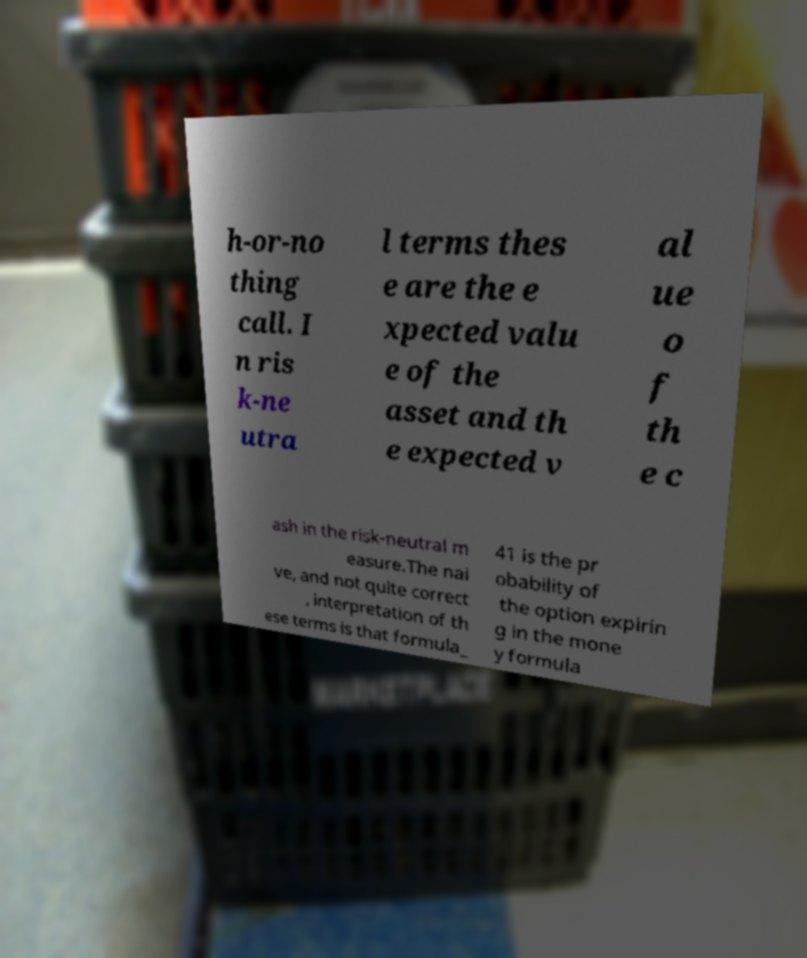I need the written content from this picture converted into text. Can you do that? h-or-no thing call. I n ris k-ne utra l terms thes e are the e xpected valu e of the asset and th e expected v al ue o f th e c ash in the risk-neutral m easure.The nai ve, and not quite correct , interpretation of th ese terms is that formula_ 41 is the pr obability of the option expirin g in the mone y formula 